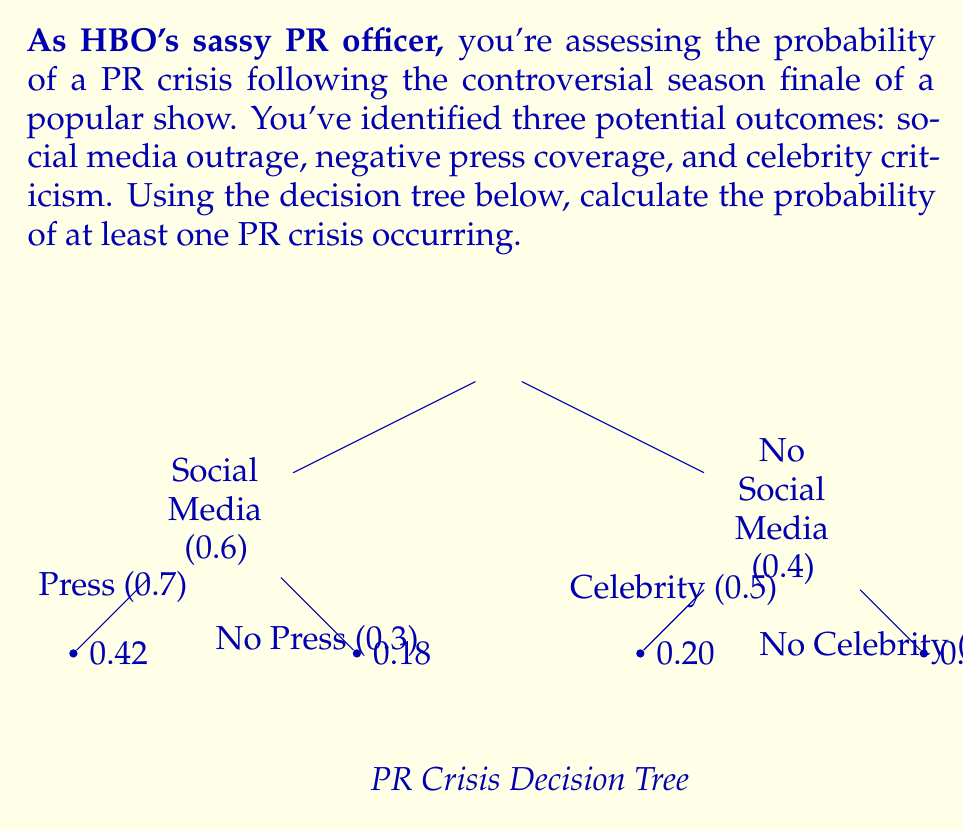Can you answer this question? Let's approach this step-by-step, using the complement method:

1) First, we need to calculate the probability of no PR crisis occurring. This would mean no social media outrage, no negative press coverage, and no celebrity criticism.

2) From the decision tree, we can see:
   - Probability of no social media outrage: 0.4
   - Given no social media outrage, probability of no negative press: 0.5
   - Given no social media outrage and no negative press, probability of no celebrity criticism: 0.5

3) The probability of all three not occurring is:

   $$ P(\text{no crisis}) = 0.4 \times 0.5 \times 0.5 = 0.1 $$

4) Therefore, the probability of at least one PR crisis occurring is the complement of this:

   $$ P(\text{at least one crisis}) = 1 - P(\text{no crisis}) = 1 - 0.1 = 0.9 $$

5) We can verify this using the probabilities given at the end points of the decision tree:
   $$ 0.42 + 0.18 + 0.20 + 0.20 = 1.00 $$
   
   The sum of all probabilities where at least one crisis occurs:
   $$ 0.42 + 0.18 + 0.20 = 0.80 $$

   This differs from our calculated result due to rounding in the displayed probabilities.
Answer: The probability of at least one PR crisis occurring is 0.9 or 90%. 